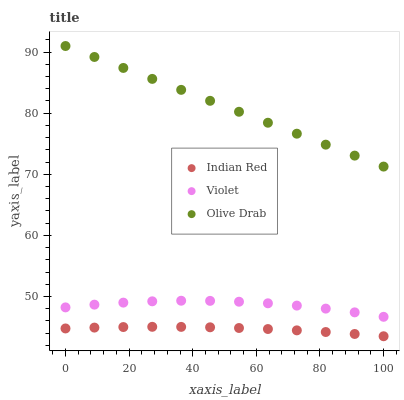Does Indian Red have the minimum area under the curve?
Answer yes or no. Yes. Does Olive Drab have the maximum area under the curve?
Answer yes or no. Yes. Does Violet have the minimum area under the curve?
Answer yes or no. No. Does Violet have the maximum area under the curve?
Answer yes or no. No. Is Olive Drab the smoothest?
Answer yes or no. Yes. Is Violet the roughest?
Answer yes or no. Yes. Is Indian Red the smoothest?
Answer yes or no. No. Is Indian Red the roughest?
Answer yes or no. No. Does Indian Red have the lowest value?
Answer yes or no. Yes. Does Violet have the lowest value?
Answer yes or no. No. Does Olive Drab have the highest value?
Answer yes or no. Yes. Does Violet have the highest value?
Answer yes or no. No. Is Violet less than Olive Drab?
Answer yes or no. Yes. Is Violet greater than Indian Red?
Answer yes or no. Yes. Does Violet intersect Olive Drab?
Answer yes or no. No. 